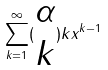<formula> <loc_0><loc_0><loc_500><loc_500>\sum _ { k = 1 } ^ { \infty } ( \begin{matrix} \alpha \\ k \end{matrix} ) k x ^ { k - 1 }</formula> 